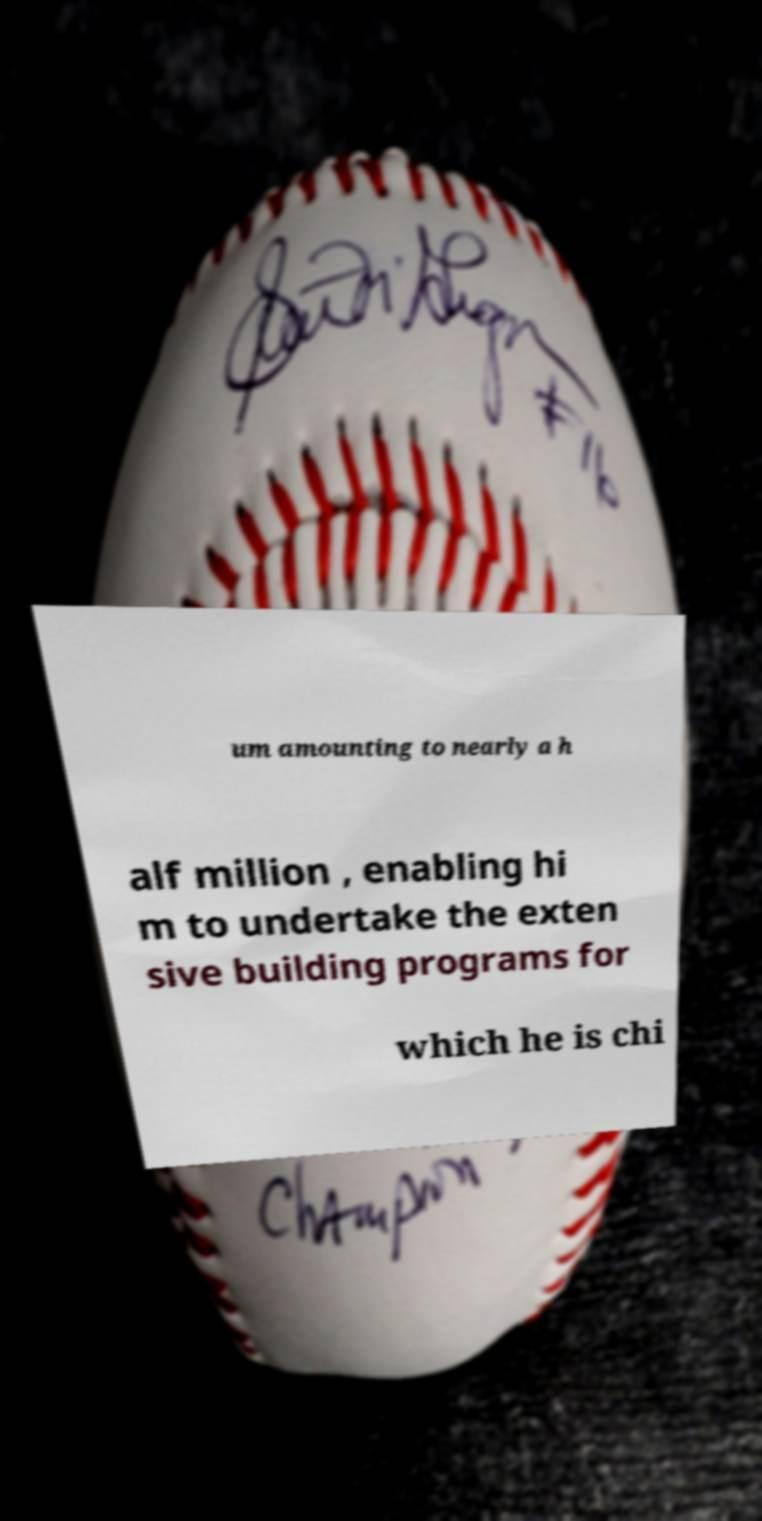Please read and relay the text visible in this image. What does it say? um amounting to nearly a h alf million , enabling hi m to undertake the exten sive building programs for which he is chi 